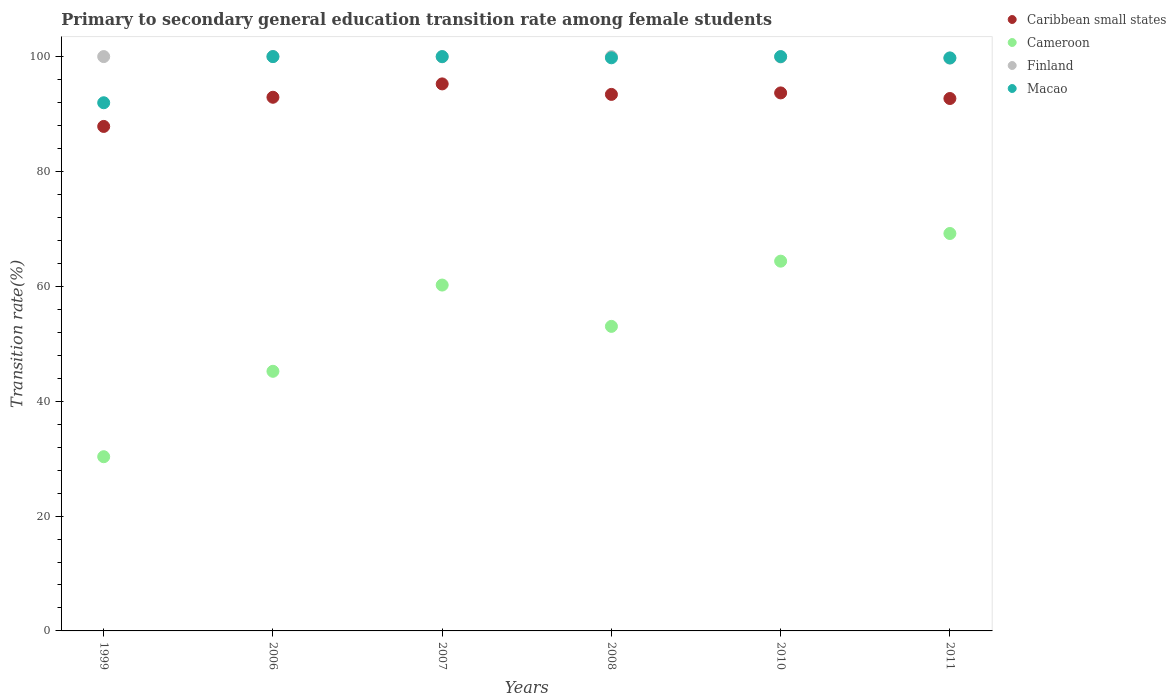How many different coloured dotlines are there?
Offer a terse response. 4. Across all years, what is the maximum transition rate in Finland?
Your answer should be very brief. 100. Across all years, what is the minimum transition rate in Macao?
Your answer should be very brief. 91.96. What is the total transition rate in Cameroon in the graph?
Your answer should be very brief. 322.36. What is the difference between the transition rate in Macao in 1999 and that in 2006?
Provide a short and direct response. -8.04. What is the difference between the transition rate in Caribbean small states in 1999 and the transition rate in Finland in 2007?
Your answer should be very brief. -12.12. What is the average transition rate in Macao per year?
Give a very brief answer. 98.59. In the year 1999, what is the difference between the transition rate in Cameroon and transition rate in Caribbean small states?
Your answer should be very brief. -57.51. What is the ratio of the transition rate in Finland in 2007 to that in 2008?
Your response must be concise. 1. Is the difference between the transition rate in Cameroon in 2006 and 2010 greater than the difference between the transition rate in Caribbean small states in 2006 and 2010?
Offer a very short reply. No. What is the difference between the highest and the lowest transition rate in Cameroon?
Your answer should be compact. 38.87. Is it the case that in every year, the sum of the transition rate in Finland and transition rate in Caribbean small states  is greater than the sum of transition rate in Cameroon and transition rate in Macao?
Provide a succinct answer. Yes. Is the transition rate in Macao strictly greater than the transition rate in Finland over the years?
Provide a succinct answer. No. How many dotlines are there?
Ensure brevity in your answer.  4. How many years are there in the graph?
Provide a succinct answer. 6. What is the difference between two consecutive major ticks on the Y-axis?
Make the answer very short. 20. Where does the legend appear in the graph?
Give a very brief answer. Top right. How many legend labels are there?
Ensure brevity in your answer.  4. How are the legend labels stacked?
Your answer should be very brief. Vertical. What is the title of the graph?
Provide a succinct answer. Primary to secondary general education transition rate among female students. Does "Azerbaijan" appear as one of the legend labels in the graph?
Give a very brief answer. No. What is the label or title of the Y-axis?
Ensure brevity in your answer.  Transition rate(%). What is the Transition rate(%) in Caribbean small states in 1999?
Ensure brevity in your answer.  87.84. What is the Transition rate(%) in Cameroon in 1999?
Offer a very short reply. 30.33. What is the Transition rate(%) of Finland in 1999?
Offer a very short reply. 100. What is the Transition rate(%) of Macao in 1999?
Provide a succinct answer. 91.96. What is the Transition rate(%) of Caribbean small states in 2006?
Make the answer very short. 92.92. What is the Transition rate(%) in Cameroon in 2006?
Provide a succinct answer. 45.2. What is the Transition rate(%) in Caribbean small states in 2007?
Keep it short and to the point. 95.24. What is the Transition rate(%) of Cameroon in 2007?
Make the answer very short. 60.22. What is the Transition rate(%) of Finland in 2007?
Your answer should be very brief. 99.96. What is the Transition rate(%) in Macao in 2007?
Offer a terse response. 100. What is the Transition rate(%) of Caribbean small states in 2008?
Provide a short and direct response. 93.41. What is the Transition rate(%) in Cameroon in 2008?
Your answer should be very brief. 53.03. What is the Transition rate(%) in Macao in 2008?
Offer a terse response. 99.79. What is the Transition rate(%) of Caribbean small states in 2010?
Ensure brevity in your answer.  93.67. What is the Transition rate(%) in Cameroon in 2010?
Provide a succinct answer. 64.38. What is the Transition rate(%) in Finland in 2010?
Your response must be concise. 99.94. What is the Transition rate(%) in Caribbean small states in 2011?
Your response must be concise. 92.7. What is the Transition rate(%) of Cameroon in 2011?
Keep it short and to the point. 69.2. What is the Transition rate(%) in Finland in 2011?
Ensure brevity in your answer.  99.73. What is the Transition rate(%) in Macao in 2011?
Keep it short and to the point. 99.76. Across all years, what is the maximum Transition rate(%) in Caribbean small states?
Provide a succinct answer. 95.24. Across all years, what is the maximum Transition rate(%) of Cameroon?
Give a very brief answer. 69.2. Across all years, what is the maximum Transition rate(%) in Macao?
Keep it short and to the point. 100. Across all years, what is the minimum Transition rate(%) in Caribbean small states?
Provide a short and direct response. 87.84. Across all years, what is the minimum Transition rate(%) of Cameroon?
Make the answer very short. 30.33. Across all years, what is the minimum Transition rate(%) in Finland?
Your response must be concise. 99.73. Across all years, what is the minimum Transition rate(%) of Macao?
Provide a succinct answer. 91.96. What is the total Transition rate(%) in Caribbean small states in the graph?
Provide a short and direct response. 555.79. What is the total Transition rate(%) of Cameroon in the graph?
Make the answer very short. 322.36. What is the total Transition rate(%) of Finland in the graph?
Provide a short and direct response. 599.63. What is the total Transition rate(%) in Macao in the graph?
Provide a succinct answer. 591.51. What is the difference between the Transition rate(%) of Caribbean small states in 1999 and that in 2006?
Keep it short and to the point. -5.08. What is the difference between the Transition rate(%) in Cameroon in 1999 and that in 2006?
Keep it short and to the point. -14.87. What is the difference between the Transition rate(%) of Finland in 1999 and that in 2006?
Make the answer very short. 0. What is the difference between the Transition rate(%) of Macao in 1999 and that in 2006?
Ensure brevity in your answer.  -8.04. What is the difference between the Transition rate(%) in Caribbean small states in 1999 and that in 2007?
Provide a short and direct response. -7.4. What is the difference between the Transition rate(%) of Cameroon in 1999 and that in 2007?
Give a very brief answer. -29.89. What is the difference between the Transition rate(%) of Finland in 1999 and that in 2007?
Ensure brevity in your answer.  0.04. What is the difference between the Transition rate(%) of Macao in 1999 and that in 2007?
Offer a very short reply. -8.04. What is the difference between the Transition rate(%) of Caribbean small states in 1999 and that in 2008?
Your answer should be very brief. -5.58. What is the difference between the Transition rate(%) of Cameroon in 1999 and that in 2008?
Your answer should be compact. -22.69. What is the difference between the Transition rate(%) of Macao in 1999 and that in 2008?
Your answer should be very brief. -7.83. What is the difference between the Transition rate(%) of Caribbean small states in 1999 and that in 2010?
Your response must be concise. -5.84. What is the difference between the Transition rate(%) in Cameroon in 1999 and that in 2010?
Your response must be concise. -34.05. What is the difference between the Transition rate(%) of Finland in 1999 and that in 2010?
Your response must be concise. 0.06. What is the difference between the Transition rate(%) in Macao in 1999 and that in 2010?
Give a very brief answer. -8.04. What is the difference between the Transition rate(%) in Caribbean small states in 1999 and that in 2011?
Provide a succinct answer. -4.86. What is the difference between the Transition rate(%) in Cameroon in 1999 and that in 2011?
Provide a succinct answer. -38.87. What is the difference between the Transition rate(%) in Finland in 1999 and that in 2011?
Ensure brevity in your answer.  0.27. What is the difference between the Transition rate(%) of Macao in 1999 and that in 2011?
Provide a short and direct response. -7.8. What is the difference between the Transition rate(%) in Caribbean small states in 2006 and that in 2007?
Your answer should be compact. -2.33. What is the difference between the Transition rate(%) in Cameroon in 2006 and that in 2007?
Your answer should be compact. -15.02. What is the difference between the Transition rate(%) in Finland in 2006 and that in 2007?
Keep it short and to the point. 0.04. What is the difference between the Transition rate(%) of Macao in 2006 and that in 2007?
Give a very brief answer. 0. What is the difference between the Transition rate(%) of Caribbean small states in 2006 and that in 2008?
Provide a succinct answer. -0.5. What is the difference between the Transition rate(%) of Cameroon in 2006 and that in 2008?
Give a very brief answer. -7.82. What is the difference between the Transition rate(%) of Finland in 2006 and that in 2008?
Offer a very short reply. 0. What is the difference between the Transition rate(%) in Macao in 2006 and that in 2008?
Your answer should be very brief. 0.21. What is the difference between the Transition rate(%) of Caribbean small states in 2006 and that in 2010?
Offer a very short reply. -0.76. What is the difference between the Transition rate(%) in Cameroon in 2006 and that in 2010?
Offer a very short reply. -19.18. What is the difference between the Transition rate(%) of Finland in 2006 and that in 2010?
Give a very brief answer. 0.06. What is the difference between the Transition rate(%) in Caribbean small states in 2006 and that in 2011?
Your answer should be compact. 0.22. What is the difference between the Transition rate(%) in Cameroon in 2006 and that in 2011?
Your answer should be very brief. -24. What is the difference between the Transition rate(%) in Finland in 2006 and that in 2011?
Provide a short and direct response. 0.27. What is the difference between the Transition rate(%) in Macao in 2006 and that in 2011?
Your answer should be compact. 0.24. What is the difference between the Transition rate(%) of Caribbean small states in 2007 and that in 2008?
Keep it short and to the point. 1.83. What is the difference between the Transition rate(%) of Cameroon in 2007 and that in 2008?
Make the answer very short. 7.19. What is the difference between the Transition rate(%) of Finland in 2007 and that in 2008?
Provide a succinct answer. -0.04. What is the difference between the Transition rate(%) of Macao in 2007 and that in 2008?
Keep it short and to the point. 0.21. What is the difference between the Transition rate(%) of Caribbean small states in 2007 and that in 2010?
Offer a terse response. 1.57. What is the difference between the Transition rate(%) of Cameroon in 2007 and that in 2010?
Your response must be concise. -4.16. What is the difference between the Transition rate(%) of Finland in 2007 and that in 2010?
Your response must be concise. 0.02. What is the difference between the Transition rate(%) in Caribbean small states in 2007 and that in 2011?
Ensure brevity in your answer.  2.54. What is the difference between the Transition rate(%) of Cameroon in 2007 and that in 2011?
Provide a succinct answer. -8.98. What is the difference between the Transition rate(%) of Finland in 2007 and that in 2011?
Give a very brief answer. 0.23. What is the difference between the Transition rate(%) of Macao in 2007 and that in 2011?
Offer a terse response. 0.24. What is the difference between the Transition rate(%) of Caribbean small states in 2008 and that in 2010?
Give a very brief answer. -0.26. What is the difference between the Transition rate(%) in Cameroon in 2008 and that in 2010?
Ensure brevity in your answer.  -11.35. What is the difference between the Transition rate(%) of Finland in 2008 and that in 2010?
Make the answer very short. 0.06. What is the difference between the Transition rate(%) in Macao in 2008 and that in 2010?
Give a very brief answer. -0.21. What is the difference between the Transition rate(%) in Caribbean small states in 2008 and that in 2011?
Your answer should be compact. 0.71. What is the difference between the Transition rate(%) of Cameroon in 2008 and that in 2011?
Ensure brevity in your answer.  -16.17. What is the difference between the Transition rate(%) in Finland in 2008 and that in 2011?
Ensure brevity in your answer.  0.27. What is the difference between the Transition rate(%) in Macao in 2008 and that in 2011?
Ensure brevity in your answer.  0.02. What is the difference between the Transition rate(%) of Caribbean small states in 2010 and that in 2011?
Your answer should be compact. 0.97. What is the difference between the Transition rate(%) in Cameroon in 2010 and that in 2011?
Ensure brevity in your answer.  -4.82. What is the difference between the Transition rate(%) in Finland in 2010 and that in 2011?
Keep it short and to the point. 0.2. What is the difference between the Transition rate(%) in Macao in 2010 and that in 2011?
Provide a short and direct response. 0.24. What is the difference between the Transition rate(%) in Caribbean small states in 1999 and the Transition rate(%) in Cameroon in 2006?
Provide a succinct answer. 42.64. What is the difference between the Transition rate(%) of Caribbean small states in 1999 and the Transition rate(%) of Finland in 2006?
Provide a short and direct response. -12.16. What is the difference between the Transition rate(%) of Caribbean small states in 1999 and the Transition rate(%) of Macao in 2006?
Make the answer very short. -12.16. What is the difference between the Transition rate(%) of Cameroon in 1999 and the Transition rate(%) of Finland in 2006?
Make the answer very short. -69.67. What is the difference between the Transition rate(%) of Cameroon in 1999 and the Transition rate(%) of Macao in 2006?
Your response must be concise. -69.67. What is the difference between the Transition rate(%) in Caribbean small states in 1999 and the Transition rate(%) in Cameroon in 2007?
Provide a short and direct response. 27.62. What is the difference between the Transition rate(%) of Caribbean small states in 1999 and the Transition rate(%) of Finland in 2007?
Ensure brevity in your answer.  -12.12. What is the difference between the Transition rate(%) of Caribbean small states in 1999 and the Transition rate(%) of Macao in 2007?
Provide a succinct answer. -12.16. What is the difference between the Transition rate(%) in Cameroon in 1999 and the Transition rate(%) in Finland in 2007?
Your response must be concise. -69.63. What is the difference between the Transition rate(%) of Cameroon in 1999 and the Transition rate(%) of Macao in 2007?
Offer a very short reply. -69.67. What is the difference between the Transition rate(%) of Caribbean small states in 1999 and the Transition rate(%) of Cameroon in 2008?
Ensure brevity in your answer.  34.81. What is the difference between the Transition rate(%) in Caribbean small states in 1999 and the Transition rate(%) in Finland in 2008?
Offer a terse response. -12.16. What is the difference between the Transition rate(%) in Caribbean small states in 1999 and the Transition rate(%) in Macao in 2008?
Your response must be concise. -11.95. What is the difference between the Transition rate(%) of Cameroon in 1999 and the Transition rate(%) of Finland in 2008?
Provide a short and direct response. -69.67. What is the difference between the Transition rate(%) of Cameroon in 1999 and the Transition rate(%) of Macao in 2008?
Offer a very short reply. -69.46. What is the difference between the Transition rate(%) in Finland in 1999 and the Transition rate(%) in Macao in 2008?
Your answer should be compact. 0.21. What is the difference between the Transition rate(%) of Caribbean small states in 1999 and the Transition rate(%) of Cameroon in 2010?
Keep it short and to the point. 23.46. What is the difference between the Transition rate(%) in Caribbean small states in 1999 and the Transition rate(%) in Finland in 2010?
Provide a short and direct response. -12.1. What is the difference between the Transition rate(%) of Caribbean small states in 1999 and the Transition rate(%) of Macao in 2010?
Make the answer very short. -12.16. What is the difference between the Transition rate(%) of Cameroon in 1999 and the Transition rate(%) of Finland in 2010?
Make the answer very short. -69.6. What is the difference between the Transition rate(%) of Cameroon in 1999 and the Transition rate(%) of Macao in 2010?
Offer a very short reply. -69.67. What is the difference between the Transition rate(%) in Caribbean small states in 1999 and the Transition rate(%) in Cameroon in 2011?
Keep it short and to the point. 18.64. What is the difference between the Transition rate(%) in Caribbean small states in 1999 and the Transition rate(%) in Finland in 2011?
Keep it short and to the point. -11.9. What is the difference between the Transition rate(%) in Caribbean small states in 1999 and the Transition rate(%) in Macao in 2011?
Keep it short and to the point. -11.93. What is the difference between the Transition rate(%) of Cameroon in 1999 and the Transition rate(%) of Finland in 2011?
Your answer should be compact. -69.4. What is the difference between the Transition rate(%) in Cameroon in 1999 and the Transition rate(%) in Macao in 2011?
Offer a terse response. -69.43. What is the difference between the Transition rate(%) of Finland in 1999 and the Transition rate(%) of Macao in 2011?
Make the answer very short. 0.24. What is the difference between the Transition rate(%) in Caribbean small states in 2006 and the Transition rate(%) in Cameroon in 2007?
Make the answer very short. 32.7. What is the difference between the Transition rate(%) in Caribbean small states in 2006 and the Transition rate(%) in Finland in 2007?
Your answer should be very brief. -7.04. What is the difference between the Transition rate(%) in Caribbean small states in 2006 and the Transition rate(%) in Macao in 2007?
Make the answer very short. -7.08. What is the difference between the Transition rate(%) in Cameroon in 2006 and the Transition rate(%) in Finland in 2007?
Your answer should be compact. -54.76. What is the difference between the Transition rate(%) of Cameroon in 2006 and the Transition rate(%) of Macao in 2007?
Ensure brevity in your answer.  -54.8. What is the difference between the Transition rate(%) in Caribbean small states in 2006 and the Transition rate(%) in Cameroon in 2008?
Your response must be concise. 39.89. What is the difference between the Transition rate(%) of Caribbean small states in 2006 and the Transition rate(%) of Finland in 2008?
Make the answer very short. -7.08. What is the difference between the Transition rate(%) of Caribbean small states in 2006 and the Transition rate(%) of Macao in 2008?
Provide a short and direct response. -6.87. What is the difference between the Transition rate(%) of Cameroon in 2006 and the Transition rate(%) of Finland in 2008?
Provide a short and direct response. -54.8. What is the difference between the Transition rate(%) in Cameroon in 2006 and the Transition rate(%) in Macao in 2008?
Provide a short and direct response. -54.59. What is the difference between the Transition rate(%) in Finland in 2006 and the Transition rate(%) in Macao in 2008?
Offer a very short reply. 0.21. What is the difference between the Transition rate(%) in Caribbean small states in 2006 and the Transition rate(%) in Cameroon in 2010?
Ensure brevity in your answer.  28.54. What is the difference between the Transition rate(%) in Caribbean small states in 2006 and the Transition rate(%) in Finland in 2010?
Ensure brevity in your answer.  -7.02. What is the difference between the Transition rate(%) of Caribbean small states in 2006 and the Transition rate(%) of Macao in 2010?
Your answer should be compact. -7.08. What is the difference between the Transition rate(%) of Cameroon in 2006 and the Transition rate(%) of Finland in 2010?
Keep it short and to the point. -54.73. What is the difference between the Transition rate(%) of Cameroon in 2006 and the Transition rate(%) of Macao in 2010?
Make the answer very short. -54.8. What is the difference between the Transition rate(%) of Finland in 2006 and the Transition rate(%) of Macao in 2010?
Give a very brief answer. 0. What is the difference between the Transition rate(%) in Caribbean small states in 2006 and the Transition rate(%) in Cameroon in 2011?
Your answer should be very brief. 23.72. What is the difference between the Transition rate(%) of Caribbean small states in 2006 and the Transition rate(%) of Finland in 2011?
Provide a succinct answer. -6.82. What is the difference between the Transition rate(%) in Caribbean small states in 2006 and the Transition rate(%) in Macao in 2011?
Provide a short and direct response. -6.85. What is the difference between the Transition rate(%) in Cameroon in 2006 and the Transition rate(%) in Finland in 2011?
Your response must be concise. -54.53. What is the difference between the Transition rate(%) of Cameroon in 2006 and the Transition rate(%) of Macao in 2011?
Provide a short and direct response. -54.56. What is the difference between the Transition rate(%) in Finland in 2006 and the Transition rate(%) in Macao in 2011?
Give a very brief answer. 0.24. What is the difference between the Transition rate(%) in Caribbean small states in 2007 and the Transition rate(%) in Cameroon in 2008?
Provide a short and direct response. 42.22. What is the difference between the Transition rate(%) of Caribbean small states in 2007 and the Transition rate(%) of Finland in 2008?
Your answer should be compact. -4.76. What is the difference between the Transition rate(%) of Caribbean small states in 2007 and the Transition rate(%) of Macao in 2008?
Offer a very short reply. -4.55. What is the difference between the Transition rate(%) of Cameroon in 2007 and the Transition rate(%) of Finland in 2008?
Offer a terse response. -39.78. What is the difference between the Transition rate(%) in Cameroon in 2007 and the Transition rate(%) in Macao in 2008?
Give a very brief answer. -39.57. What is the difference between the Transition rate(%) in Finland in 2007 and the Transition rate(%) in Macao in 2008?
Give a very brief answer. 0.17. What is the difference between the Transition rate(%) of Caribbean small states in 2007 and the Transition rate(%) of Cameroon in 2010?
Provide a succinct answer. 30.86. What is the difference between the Transition rate(%) in Caribbean small states in 2007 and the Transition rate(%) in Finland in 2010?
Ensure brevity in your answer.  -4.69. What is the difference between the Transition rate(%) in Caribbean small states in 2007 and the Transition rate(%) in Macao in 2010?
Your answer should be compact. -4.76. What is the difference between the Transition rate(%) of Cameroon in 2007 and the Transition rate(%) of Finland in 2010?
Offer a very short reply. -39.72. What is the difference between the Transition rate(%) of Cameroon in 2007 and the Transition rate(%) of Macao in 2010?
Offer a very short reply. -39.78. What is the difference between the Transition rate(%) of Finland in 2007 and the Transition rate(%) of Macao in 2010?
Ensure brevity in your answer.  -0.04. What is the difference between the Transition rate(%) in Caribbean small states in 2007 and the Transition rate(%) in Cameroon in 2011?
Offer a terse response. 26.04. What is the difference between the Transition rate(%) in Caribbean small states in 2007 and the Transition rate(%) in Finland in 2011?
Give a very brief answer. -4.49. What is the difference between the Transition rate(%) in Caribbean small states in 2007 and the Transition rate(%) in Macao in 2011?
Your answer should be compact. -4.52. What is the difference between the Transition rate(%) in Cameroon in 2007 and the Transition rate(%) in Finland in 2011?
Your response must be concise. -39.52. What is the difference between the Transition rate(%) in Cameroon in 2007 and the Transition rate(%) in Macao in 2011?
Your response must be concise. -39.54. What is the difference between the Transition rate(%) in Finland in 2007 and the Transition rate(%) in Macao in 2011?
Give a very brief answer. 0.2. What is the difference between the Transition rate(%) in Caribbean small states in 2008 and the Transition rate(%) in Cameroon in 2010?
Give a very brief answer. 29.04. What is the difference between the Transition rate(%) of Caribbean small states in 2008 and the Transition rate(%) of Finland in 2010?
Give a very brief answer. -6.52. What is the difference between the Transition rate(%) in Caribbean small states in 2008 and the Transition rate(%) in Macao in 2010?
Give a very brief answer. -6.59. What is the difference between the Transition rate(%) of Cameroon in 2008 and the Transition rate(%) of Finland in 2010?
Ensure brevity in your answer.  -46.91. What is the difference between the Transition rate(%) in Cameroon in 2008 and the Transition rate(%) in Macao in 2010?
Offer a very short reply. -46.97. What is the difference between the Transition rate(%) in Finland in 2008 and the Transition rate(%) in Macao in 2010?
Provide a succinct answer. 0. What is the difference between the Transition rate(%) in Caribbean small states in 2008 and the Transition rate(%) in Cameroon in 2011?
Provide a short and direct response. 24.22. What is the difference between the Transition rate(%) of Caribbean small states in 2008 and the Transition rate(%) of Finland in 2011?
Offer a terse response. -6.32. What is the difference between the Transition rate(%) of Caribbean small states in 2008 and the Transition rate(%) of Macao in 2011?
Ensure brevity in your answer.  -6.35. What is the difference between the Transition rate(%) of Cameroon in 2008 and the Transition rate(%) of Finland in 2011?
Give a very brief answer. -46.71. What is the difference between the Transition rate(%) of Cameroon in 2008 and the Transition rate(%) of Macao in 2011?
Ensure brevity in your answer.  -46.74. What is the difference between the Transition rate(%) of Finland in 2008 and the Transition rate(%) of Macao in 2011?
Your answer should be compact. 0.24. What is the difference between the Transition rate(%) of Caribbean small states in 2010 and the Transition rate(%) of Cameroon in 2011?
Give a very brief answer. 24.48. What is the difference between the Transition rate(%) in Caribbean small states in 2010 and the Transition rate(%) in Finland in 2011?
Your answer should be very brief. -6.06. What is the difference between the Transition rate(%) of Caribbean small states in 2010 and the Transition rate(%) of Macao in 2011?
Give a very brief answer. -6.09. What is the difference between the Transition rate(%) of Cameroon in 2010 and the Transition rate(%) of Finland in 2011?
Your answer should be very brief. -35.36. What is the difference between the Transition rate(%) of Cameroon in 2010 and the Transition rate(%) of Macao in 2011?
Keep it short and to the point. -35.38. What is the difference between the Transition rate(%) in Finland in 2010 and the Transition rate(%) in Macao in 2011?
Offer a terse response. 0.17. What is the average Transition rate(%) of Caribbean small states per year?
Your response must be concise. 92.63. What is the average Transition rate(%) of Cameroon per year?
Ensure brevity in your answer.  53.73. What is the average Transition rate(%) in Finland per year?
Your answer should be compact. 99.94. What is the average Transition rate(%) of Macao per year?
Keep it short and to the point. 98.59. In the year 1999, what is the difference between the Transition rate(%) of Caribbean small states and Transition rate(%) of Cameroon?
Provide a short and direct response. 57.51. In the year 1999, what is the difference between the Transition rate(%) in Caribbean small states and Transition rate(%) in Finland?
Offer a very short reply. -12.16. In the year 1999, what is the difference between the Transition rate(%) in Caribbean small states and Transition rate(%) in Macao?
Provide a short and direct response. -4.12. In the year 1999, what is the difference between the Transition rate(%) of Cameroon and Transition rate(%) of Finland?
Your response must be concise. -69.67. In the year 1999, what is the difference between the Transition rate(%) of Cameroon and Transition rate(%) of Macao?
Offer a terse response. -61.63. In the year 1999, what is the difference between the Transition rate(%) of Finland and Transition rate(%) of Macao?
Make the answer very short. 8.04. In the year 2006, what is the difference between the Transition rate(%) in Caribbean small states and Transition rate(%) in Cameroon?
Make the answer very short. 47.72. In the year 2006, what is the difference between the Transition rate(%) of Caribbean small states and Transition rate(%) of Finland?
Make the answer very short. -7.08. In the year 2006, what is the difference between the Transition rate(%) in Caribbean small states and Transition rate(%) in Macao?
Provide a short and direct response. -7.08. In the year 2006, what is the difference between the Transition rate(%) in Cameroon and Transition rate(%) in Finland?
Give a very brief answer. -54.8. In the year 2006, what is the difference between the Transition rate(%) of Cameroon and Transition rate(%) of Macao?
Keep it short and to the point. -54.8. In the year 2007, what is the difference between the Transition rate(%) of Caribbean small states and Transition rate(%) of Cameroon?
Your response must be concise. 35.02. In the year 2007, what is the difference between the Transition rate(%) in Caribbean small states and Transition rate(%) in Finland?
Provide a succinct answer. -4.72. In the year 2007, what is the difference between the Transition rate(%) of Caribbean small states and Transition rate(%) of Macao?
Offer a terse response. -4.76. In the year 2007, what is the difference between the Transition rate(%) in Cameroon and Transition rate(%) in Finland?
Your answer should be very brief. -39.74. In the year 2007, what is the difference between the Transition rate(%) of Cameroon and Transition rate(%) of Macao?
Ensure brevity in your answer.  -39.78. In the year 2007, what is the difference between the Transition rate(%) of Finland and Transition rate(%) of Macao?
Your response must be concise. -0.04. In the year 2008, what is the difference between the Transition rate(%) in Caribbean small states and Transition rate(%) in Cameroon?
Provide a short and direct response. 40.39. In the year 2008, what is the difference between the Transition rate(%) of Caribbean small states and Transition rate(%) of Finland?
Provide a succinct answer. -6.59. In the year 2008, what is the difference between the Transition rate(%) of Caribbean small states and Transition rate(%) of Macao?
Provide a succinct answer. -6.37. In the year 2008, what is the difference between the Transition rate(%) in Cameroon and Transition rate(%) in Finland?
Ensure brevity in your answer.  -46.97. In the year 2008, what is the difference between the Transition rate(%) in Cameroon and Transition rate(%) in Macao?
Your answer should be compact. -46.76. In the year 2008, what is the difference between the Transition rate(%) in Finland and Transition rate(%) in Macao?
Offer a very short reply. 0.21. In the year 2010, what is the difference between the Transition rate(%) of Caribbean small states and Transition rate(%) of Cameroon?
Your response must be concise. 29.3. In the year 2010, what is the difference between the Transition rate(%) in Caribbean small states and Transition rate(%) in Finland?
Ensure brevity in your answer.  -6.26. In the year 2010, what is the difference between the Transition rate(%) in Caribbean small states and Transition rate(%) in Macao?
Provide a succinct answer. -6.33. In the year 2010, what is the difference between the Transition rate(%) in Cameroon and Transition rate(%) in Finland?
Make the answer very short. -35.56. In the year 2010, what is the difference between the Transition rate(%) in Cameroon and Transition rate(%) in Macao?
Give a very brief answer. -35.62. In the year 2010, what is the difference between the Transition rate(%) in Finland and Transition rate(%) in Macao?
Offer a terse response. -0.06. In the year 2011, what is the difference between the Transition rate(%) in Caribbean small states and Transition rate(%) in Cameroon?
Your answer should be very brief. 23.5. In the year 2011, what is the difference between the Transition rate(%) of Caribbean small states and Transition rate(%) of Finland?
Ensure brevity in your answer.  -7.03. In the year 2011, what is the difference between the Transition rate(%) of Caribbean small states and Transition rate(%) of Macao?
Make the answer very short. -7.06. In the year 2011, what is the difference between the Transition rate(%) of Cameroon and Transition rate(%) of Finland?
Ensure brevity in your answer.  -30.54. In the year 2011, what is the difference between the Transition rate(%) of Cameroon and Transition rate(%) of Macao?
Your response must be concise. -30.57. In the year 2011, what is the difference between the Transition rate(%) in Finland and Transition rate(%) in Macao?
Ensure brevity in your answer.  -0.03. What is the ratio of the Transition rate(%) in Caribbean small states in 1999 to that in 2006?
Offer a very short reply. 0.95. What is the ratio of the Transition rate(%) in Cameroon in 1999 to that in 2006?
Ensure brevity in your answer.  0.67. What is the ratio of the Transition rate(%) of Finland in 1999 to that in 2006?
Offer a very short reply. 1. What is the ratio of the Transition rate(%) of Macao in 1999 to that in 2006?
Offer a terse response. 0.92. What is the ratio of the Transition rate(%) of Caribbean small states in 1999 to that in 2007?
Your response must be concise. 0.92. What is the ratio of the Transition rate(%) in Cameroon in 1999 to that in 2007?
Offer a terse response. 0.5. What is the ratio of the Transition rate(%) in Finland in 1999 to that in 2007?
Offer a very short reply. 1. What is the ratio of the Transition rate(%) of Macao in 1999 to that in 2007?
Offer a very short reply. 0.92. What is the ratio of the Transition rate(%) in Caribbean small states in 1999 to that in 2008?
Your answer should be compact. 0.94. What is the ratio of the Transition rate(%) of Cameroon in 1999 to that in 2008?
Offer a very short reply. 0.57. What is the ratio of the Transition rate(%) of Finland in 1999 to that in 2008?
Make the answer very short. 1. What is the ratio of the Transition rate(%) of Macao in 1999 to that in 2008?
Provide a short and direct response. 0.92. What is the ratio of the Transition rate(%) of Caribbean small states in 1999 to that in 2010?
Ensure brevity in your answer.  0.94. What is the ratio of the Transition rate(%) in Cameroon in 1999 to that in 2010?
Your response must be concise. 0.47. What is the ratio of the Transition rate(%) of Finland in 1999 to that in 2010?
Ensure brevity in your answer.  1. What is the ratio of the Transition rate(%) in Macao in 1999 to that in 2010?
Your answer should be compact. 0.92. What is the ratio of the Transition rate(%) of Caribbean small states in 1999 to that in 2011?
Give a very brief answer. 0.95. What is the ratio of the Transition rate(%) in Cameroon in 1999 to that in 2011?
Your response must be concise. 0.44. What is the ratio of the Transition rate(%) of Finland in 1999 to that in 2011?
Provide a succinct answer. 1. What is the ratio of the Transition rate(%) in Macao in 1999 to that in 2011?
Offer a terse response. 0.92. What is the ratio of the Transition rate(%) in Caribbean small states in 2006 to that in 2007?
Your response must be concise. 0.98. What is the ratio of the Transition rate(%) in Cameroon in 2006 to that in 2007?
Offer a terse response. 0.75. What is the ratio of the Transition rate(%) of Cameroon in 2006 to that in 2008?
Your answer should be very brief. 0.85. What is the ratio of the Transition rate(%) of Macao in 2006 to that in 2008?
Offer a terse response. 1. What is the ratio of the Transition rate(%) in Caribbean small states in 2006 to that in 2010?
Ensure brevity in your answer.  0.99. What is the ratio of the Transition rate(%) of Cameroon in 2006 to that in 2010?
Your answer should be very brief. 0.7. What is the ratio of the Transition rate(%) of Cameroon in 2006 to that in 2011?
Provide a succinct answer. 0.65. What is the ratio of the Transition rate(%) in Finland in 2006 to that in 2011?
Your answer should be very brief. 1. What is the ratio of the Transition rate(%) in Caribbean small states in 2007 to that in 2008?
Make the answer very short. 1.02. What is the ratio of the Transition rate(%) of Cameroon in 2007 to that in 2008?
Keep it short and to the point. 1.14. What is the ratio of the Transition rate(%) in Caribbean small states in 2007 to that in 2010?
Provide a succinct answer. 1.02. What is the ratio of the Transition rate(%) of Cameroon in 2007 to that in 2010?
Offer a terse response. 0.94. What is the ratio of the Transition rate(%) of Finland in 2007 to that in 2010?
Your answer should be very brief. 1. What is the ratio of the Transition rate(%) in Caribbean small states in 2007 to that in 2011?
Provide a short and direct response. 1.03. What is the ratio of the Transition rate(%) of Cameroon in 2007 to that in 2011?
Make the answer very short. 0.87. What is the ratio of the Transition rate(%) in Macao in 2007 to that in 2011?
Your answer should be very brief. 1. What is the ratio of the Transition rate(%) of Cameroon in 2008 to that in 2010?
Ensure brevity in your answer.  0.82. What is the ratio of the Transition rate(%) of Finland in 2008 to that in 2010?
Keep it short and to the point. 1. What is the ratio of the Transition rate(%) in Caribbean small states in 2008 to that in 2011?
Your answer should be compact. 1.01. What is the ratio of the Transition rate(%) in Cameroon in 2008 to that in 2011?
Offer a very short reply. 0.77. What is the ratio of the Transition rate(%) in Finland in 2008 to that in 2011?
Make the answer very short. 1. What is the ratio of the Transition rate(%) in Caribbean small states in 2010 to that in 2011?
Offer a very short reply. 1.01. What is the ratio of the Transition rate(%) of Cameroon in 2010 to that in 2011?
Your answer should be very brief. 0.93. What is the ratio of the Transition rate(%) of Finland in 2010 to that in 2011?
Make the answer very short. 1. What is the ratio of the Transition rate(%) in Macao in 2010 to that in 2011?
Provide a short and direct response. 1. What is the difference between the highest and the second highest Transition rate(%) of Caribbean small states?
Give a very brief answer. 1.57. What is the difference between the highest and the second highest Transition rate(%) in Cameroon?
Provide a short and direct response. 4.82. What is the difference between the highest and the second highest Transition rate(%) of Macao?
Offer a terse response. 0. What is the difference between the highest and the lowest Transition rate(%) of Caribbean small states?
Keep it short and to the point. 7.4. What is the difference between the highest and the lowest Transition rate(%) of Cameroon?
Offer a terse response. 38.87. What is the difference between the highest and the lowest Transition rate(%) in Finland?
Give a very brief answer. 0.27. What is the difference between the highest and the lowest Transition rate(%) of Macao?
Keep it short and to the point. 8.04. 